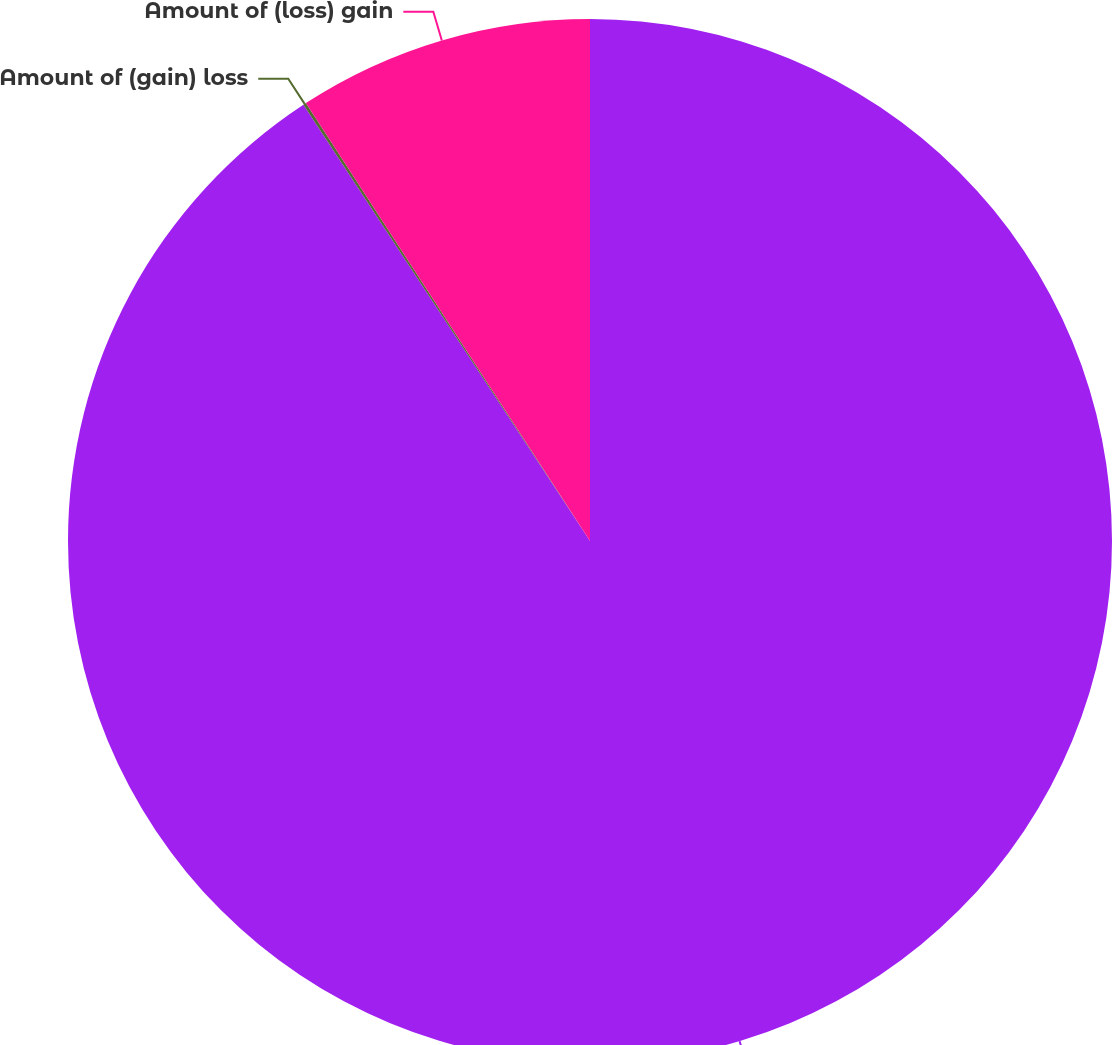Convert chart to OTSL. <chart><loc_0><loc_0><loc_500><loc_500><pie_chart><fcel>(in millions)<fcel>Amount of (gain) loss<fcel>Amount of (loss) gain<nl><fcel>90.75%<fcel>0.09%<fcel>9.16%<nl></chart> 